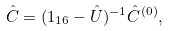Convert formula to latex. <formula><loc_0><loc_0><loc_500><loc_500>\hat { C } = ( { 1 } _ { 1 6 } - \hat { U } ) ^ { - 1 } \hat { C } ^ { ( 0 ) } ,</formula> 